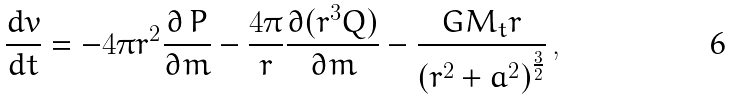Convert formula to latex. <formula><loc_0><loc_0><loc_500><loc_500>\frac { d v } { d t } = - 4 \pi r ^ { 2 } \frac { \partial \, P } { \partial m } - \frac { 4 \pi } { r } \frac { \partial ( r ^ { 3 } Q ) } { \partial m } - \frac { G M _ { t } r } { { ( r ^ { 2 } + a ^ { 2 } ) } ^ { \frac { 3 } { 2 } } } \, ,</formula> 